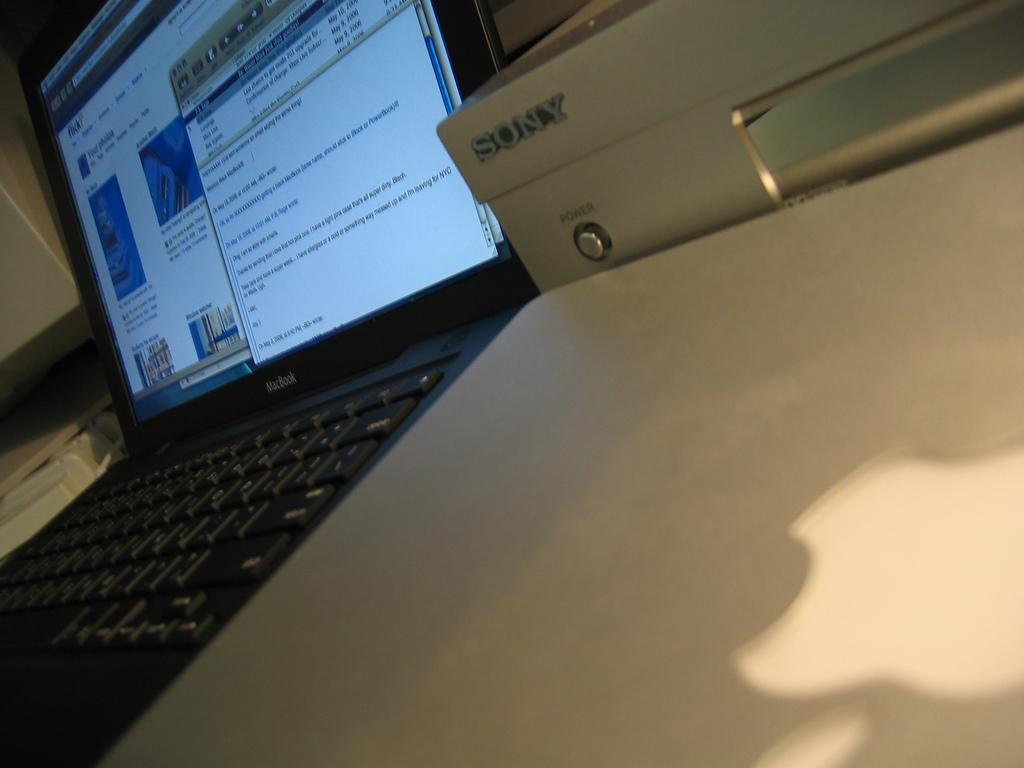What electronic device is visible in the image? There is a laptop in the image. What can be seen on the laptop's screen? Text is displayed on the screen of the laptop. What other object is present beside the laptop? There is a machine beside the laptop. What is written on the machine? Text is present on the machine. How many babies are crawling under the bridge in the image? There are no babies or bridges present in the image. 